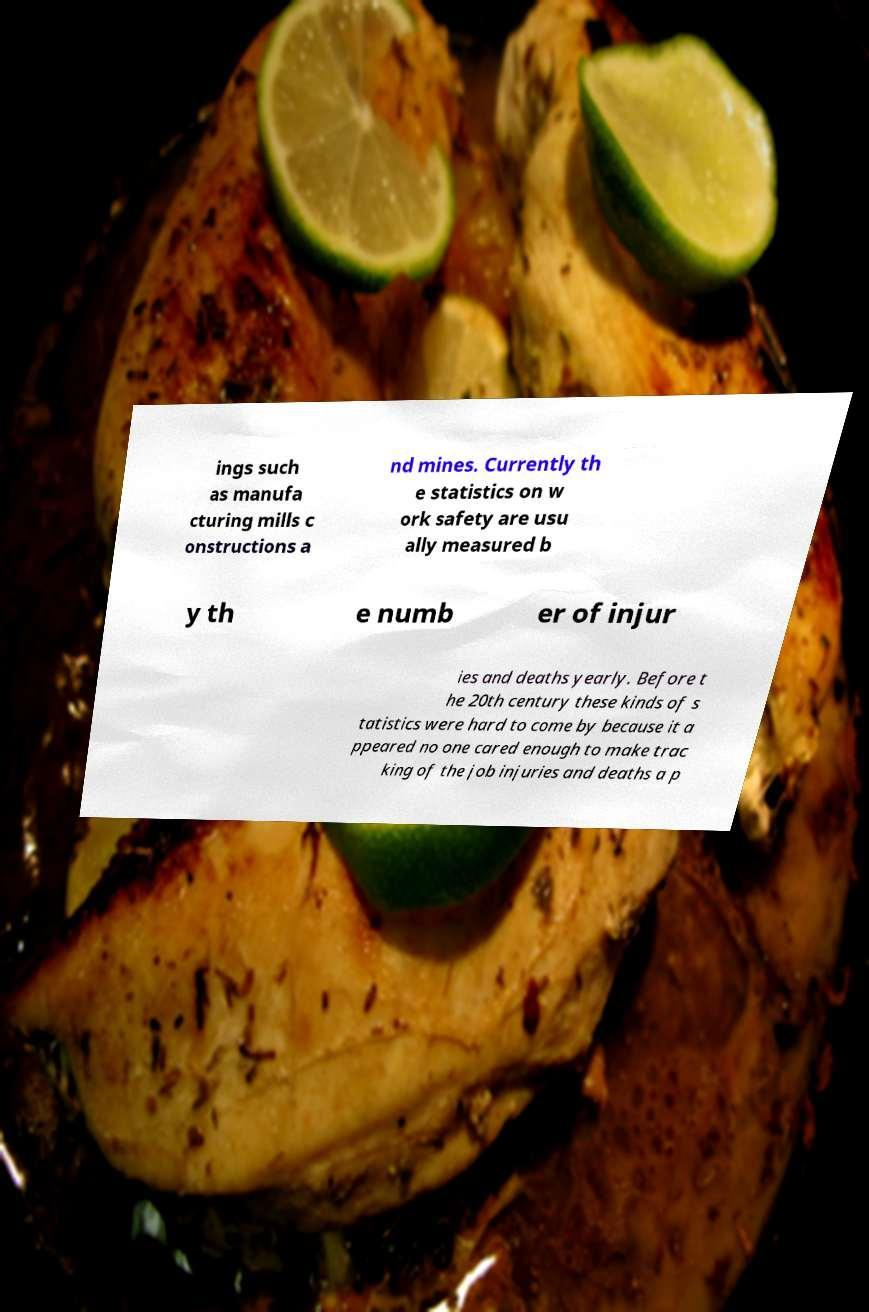I need the written content from this picture converted into text. Can you do that? ings such as manufa cturing mills c onstructions a nd mines. Currently th e statistics on w ork safety are usu ally measured b y th e numb er of injur ies and deaths yearly. Before t he 20th century these kinds of s tatistics were hard to come by because it a ppeared no one cared enough to make trac king of the job injuries and deaths a p 